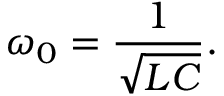<formula> <loc_0><loc_0><loc_500><loc_500>\omega _ { 0 } = { \frac { 1 } { \sqrt { L C } } } .</formula> 